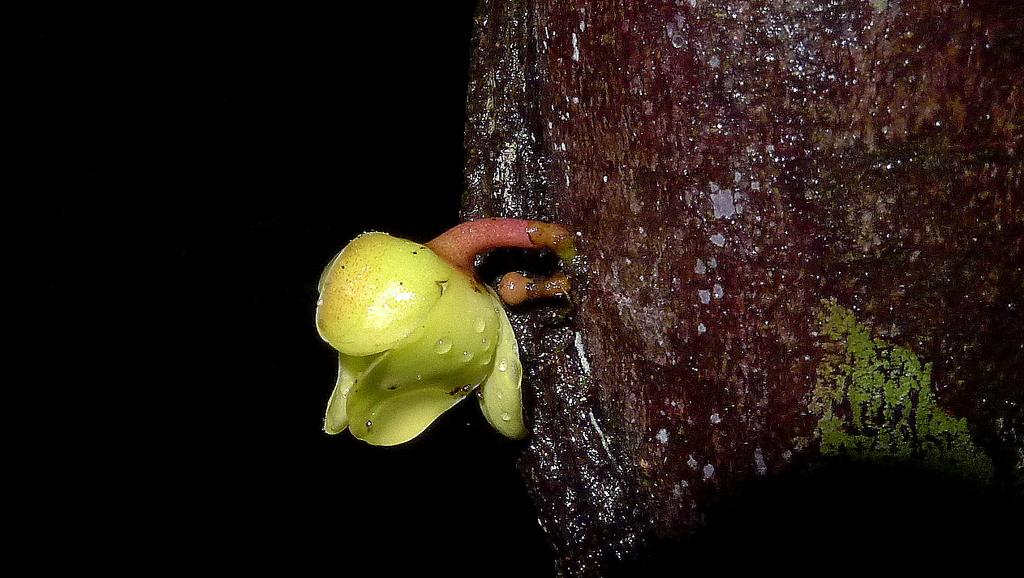What is the main subject in the center of the image? There is a flower in the center of the image. What can be seen on the right side of the image? There is bark of a tree on the right side of the image. How would you describe the left side of the image? The left side of the image appears to be dark. What type of vegetable is growing on the left side of the image? There is no vegetable present in the image; the left side appears to be dark. Can you see the tail of an animal in the image? There is no animal or tail present in the image. 